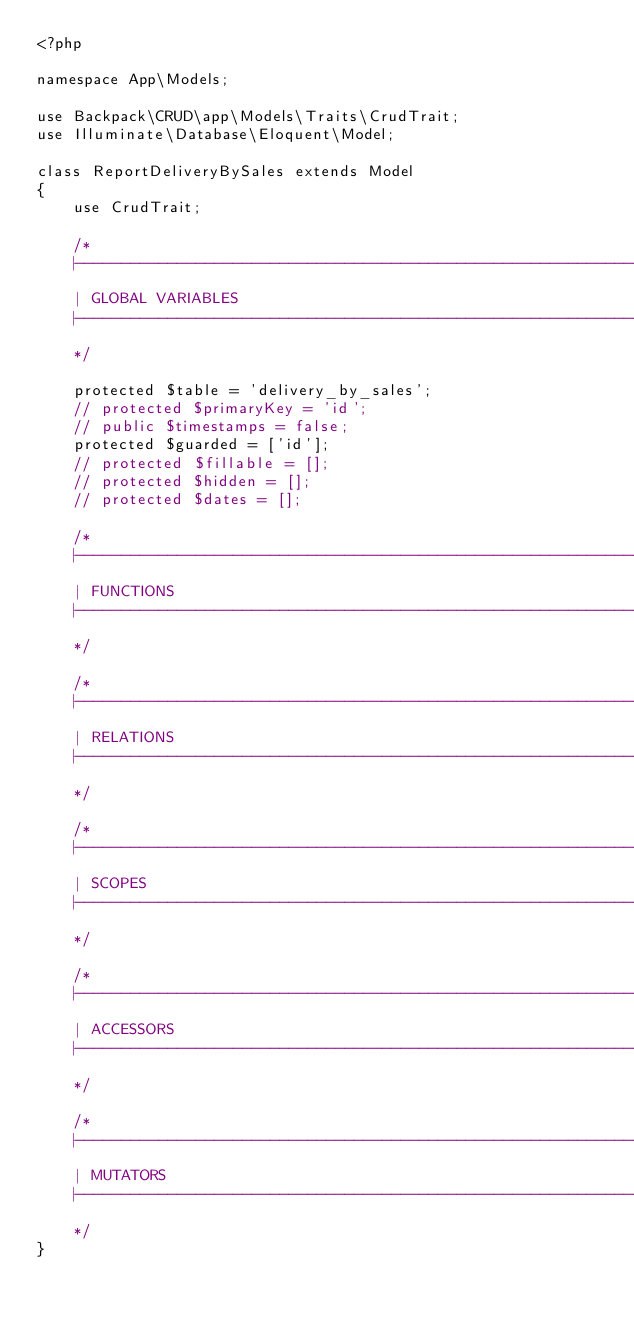Convert code to text. <code><loc_0><loc_0><loc_500><loc_500><_PHP_><?php

namespace App\Models;

use Backpack\CRUD\app\Models\Traits\CrudTrait;
use Illuminate\Database\Eloquent\Model;

class ReportDeliveryBySales extends Model
{
    use CrudTrait;

    /*
    |--------------------------------------------------------------------------
    | GLOBAL VARIABLES
    |--------------------------------------------------------------------------
    */

    protected $table = 'delivery_by_sales';
    // protected $primaryKey = 'id';
    // public $timestamps = false;
    protected $guarded = ['id'];
    // protected $fillable = [];
    // protected $hidden = [];
    // protected $dates = [];

    /*
    |--------------------------------------------------------------------------
    | FUNCTIONS
    |--------------------------------------------------------------------------
    */

    /*
    |--------------------------------------------------------------------------
    | RELATIONS
    |--------------------------------------------------------------------------
    */

    /*
    |--------------------------------------------------------------------------
    | SCOPES
    |--------------------------------------------------------------------------
    */

    /*
    |--------------------------------------------------------------------------
    | ACCESSORS
    |--------------------------------------------------------------------------
    */

    /*
    |--------------------------------------------------------------------------
    | MUTATORS
    |--------------------------------------------------------------------------
    */
}
</code> 